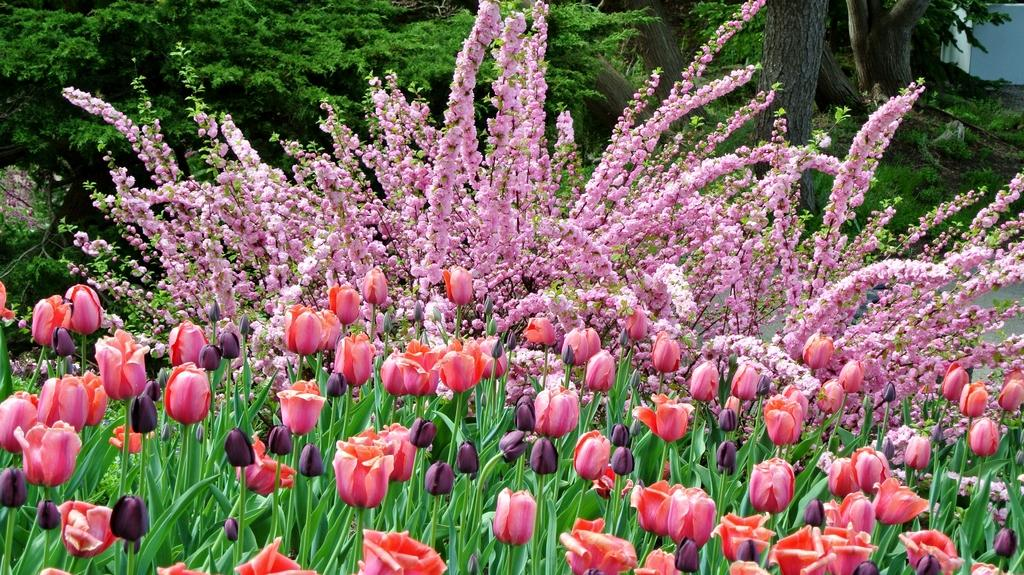What type of vegetation can be seen in the image? There are flowers, plants, and trees in the image. Can you describe the different types of vegetation present? The image contains flowers, which are smaller and more colorful, plants, which are typically green and leafy, and trees, which are larger and have a woody trunk. How many different types of vegetation are present in the image? There are three different types of vegetation present in the image: flowers, plants, and trees. What type of chair can be seen in the image? There is no chair present in the image; it features flowers, plants, and trees. 